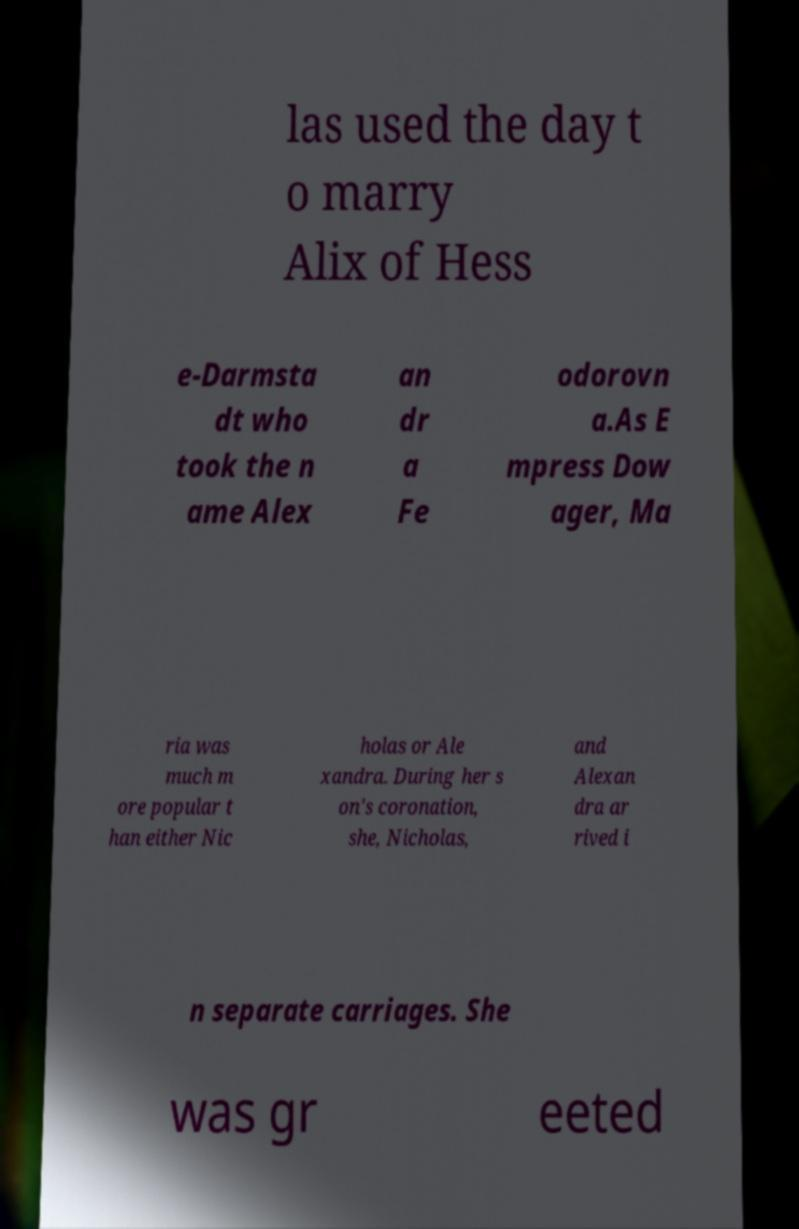What messages or text are displayed in this image? I need them in a readable, typed format. las used the day t o marry Alix of Hess e-Darmsta dt who took the n ame Alex an dr a Fe odorovn a.As E mpress Dow ager, Ma ria was much m ore popular t han either Nic holas or Ale xandra. During her s on's coronation, she, Nicholas, and Alexan dra ar rived i n separate carriages. She was gr eeted 